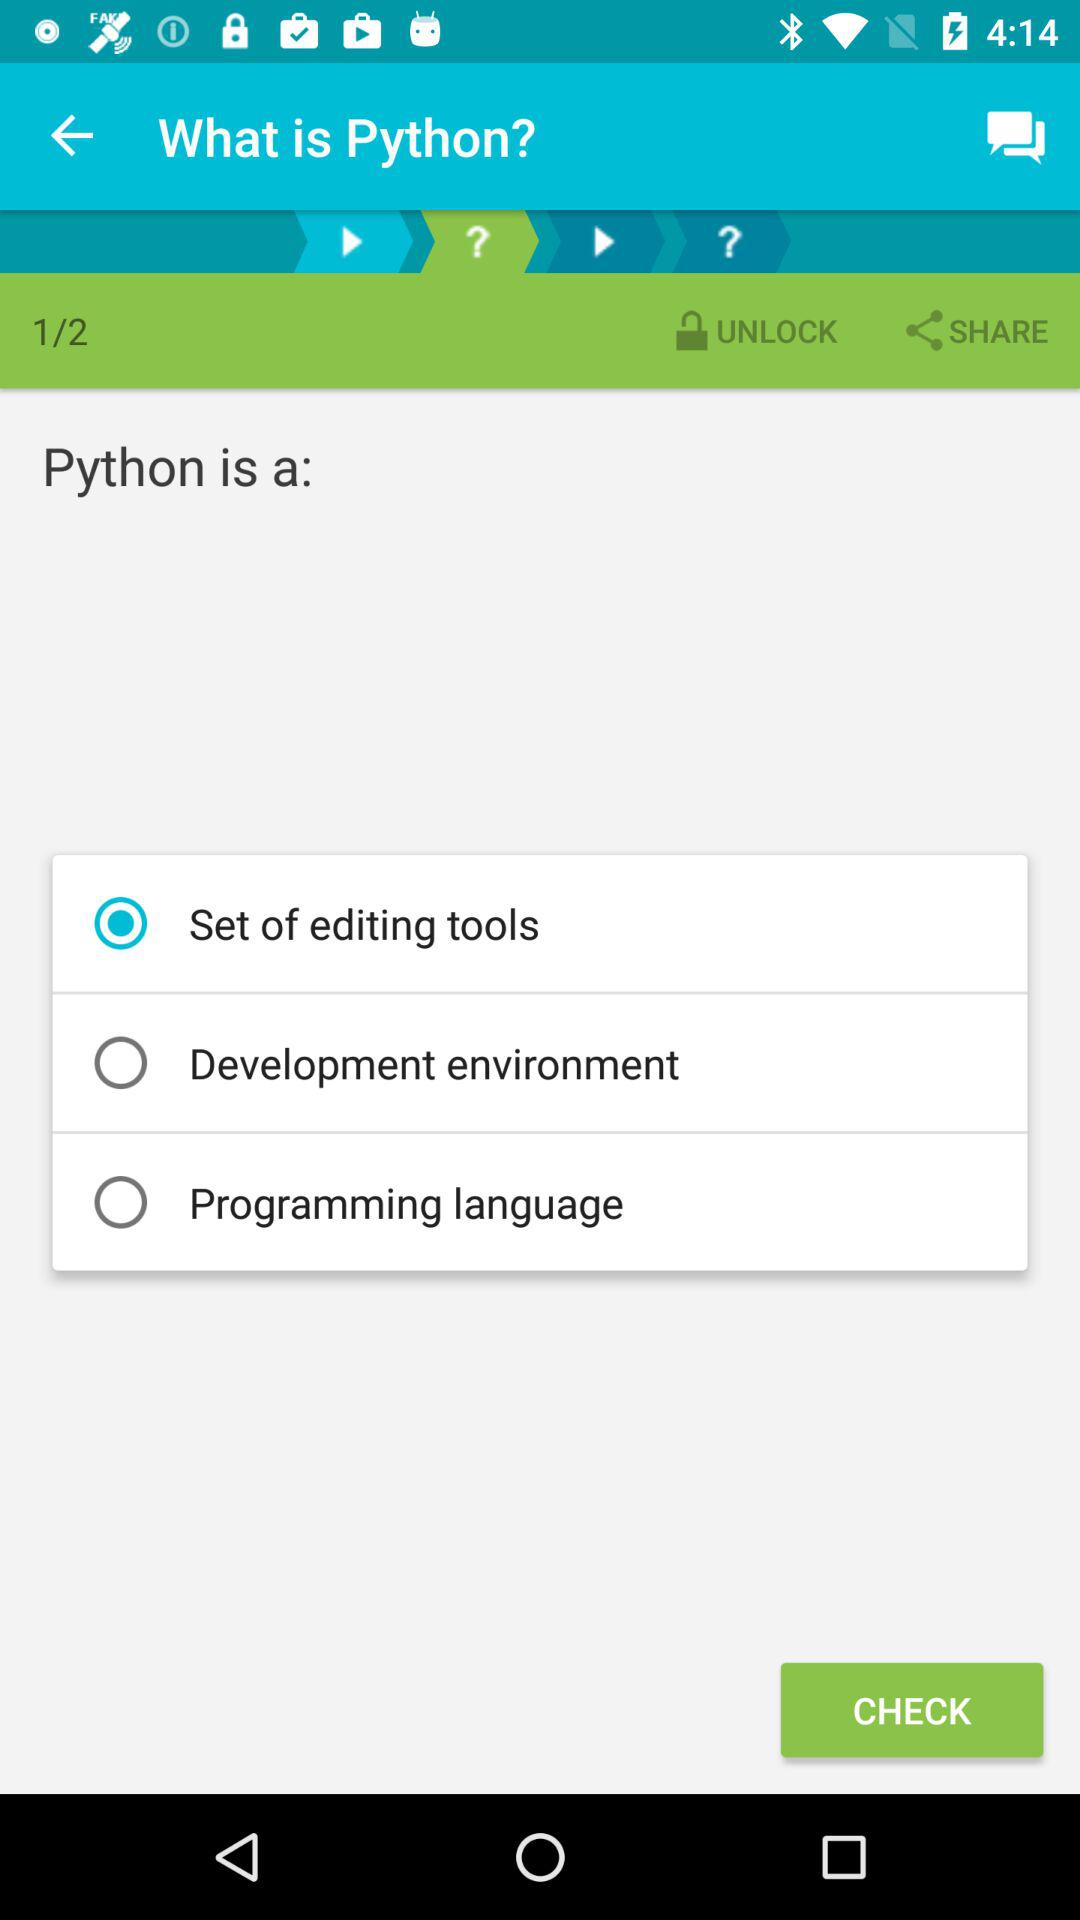Is "Set of editing tools" selected or not? "Set of editing tools" is selected. 